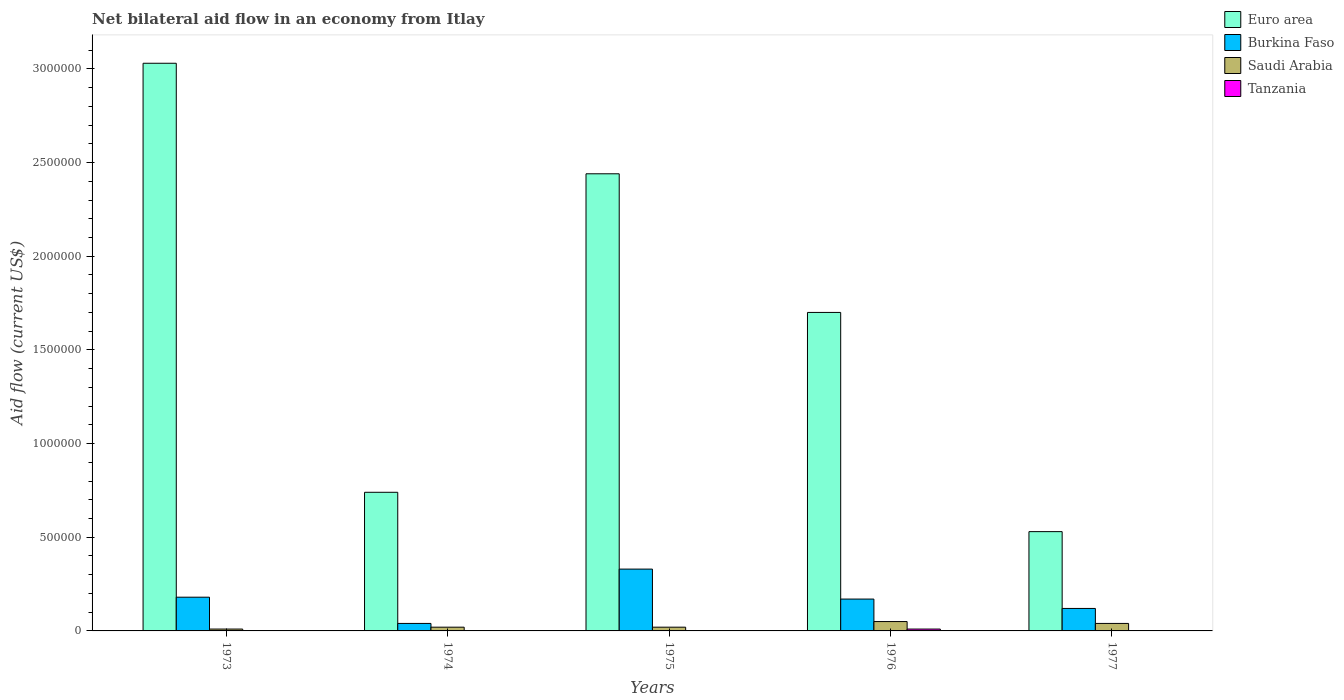How many different coloured bars are there?
Ensure brevity in your answer.  4. How many groups of bars are there?
Provide a short and direct response. 5. Are the number of bars per tick equal to the number of legend labels?
Provide a short and direct response. No. Are the number of bars on each tick of the X-axis equal?
Give a very brief answer. No. In how many cases, is the number of bars for a given year not equal to the number of legend labels?
Make the answer very short. 4. What is the net bilateral aid flow in Burkina Faso in 1974?
Your answer should be very brief. 4.00e+04. What is the total net bilateral aid flow in Euro area in the graph?
Your answer should be compact. 8.44e+06. What is the difference between the net bilateral aid flow in Euro area in 1974 and that in 1976?
Offer a very short reply. -9.60e+05. What is the difference between the net bilateral aid flow in Euro area in 1975 and the net bilateral aid flow in Burkina Faso in 1973?
Provide a succinct answer. 2.26e+06. What is the average net bilateral aid flow in Saudi Arabia per year?
Ensure brevity in your answer.  2.80e+04. In the year 1977, what is the difference between the net bilateral aid flow in Saudi Arabia and net bilateral aid flow in Euro area?
Give a very brief answer. -4.90e+05. In how many years, is the net bilateral aid flow in Burkina Faso greater than 2300000 US$?
Offer a very short reply. 0. Is the difference between the net bilateral aid flow in Saudi Arabia in 1973 and 1977 greater than the difference between the net bilateral aid flow in Euro area in 1973 and 1977?
Provide a succinct answer. No. What is the difference between the highest and the lowest net bilateral aid flow in Tanzania?
Your answer should be very brief. 10000. In how many years, is the net bilateral aid flow in Euro area greater than the average net bilateral aid flow in Euro area taken over all years?
Provide a succinct answer. 3. Is it the case that in every year, the sum of the net bilateral aid flow in Saudi Arabia and net bilateral aid flow in Tanzania is greater than the sum of net bilateral aid flow in Euro area and net bilateral aid flow in Burkina Faso?
Provide a short and direct response. No. Is it the case that in every year, the sum of the net bilateral aid flow in Burkina Faso and net bilateral aid flow in Tanzania is greater than the net bilateral aid flow in Saudi Arabia?
Your response must be concise. Yes. How many bars are there?
Ensure brevity in your answer.  16. How many years are there in the graph?
Your answer should be compact. 5. Does the graph contain any zero values?
Make the answer very short. Yes. Does the graph contain grids?
Your response must be concise. No. What is the title of the graph?
Your response must be concise. Net bilateral aid flow in an economy from Itlay. Does "Middle East & North Africa (all income levels)" appear as one of the legend labels in the graph?
Offer a terse response. No. What is the label or title of the X-axis?
Your answer should be compact. Years. What is the Aid flow (current US$) of Euro area in 1973?
Offer a very short reply. 3.03e+06. What is the Aid flow (current US$) of Saudi Arabia in 1973?
Offer a terse response. 10000. What is the Aid flow (current US$) in Euro area in 1974?
Your answer should be compact. 7.40e+05. What is the Aid flow (current US$) in Tanzania in 1974?
Your answer should be compact. 0. What is the Aid flow (current US$) in Euro area in 1975?
Your answer should be compact. 2.44e+06. What is the Aid flow (current US$) in Burkina Faso in 1975?
Your answer should be compact. 3.30e+05. What is the Aid flow (current US$) of Saudi Arabia in 1975?
Your answer should be compact. 2.00e+04. What is the Aid flow (current US$) of Euro area in 1976?
Your response must be concise. 1.70e+06. What is the Aid flow (current US$) in Burkina Faso in 1976?
Provide a short and direct response. 1.70e+05. What is the Aid flow (current US$) of Tanzania in 1976?
Give a very brief answer. 10000. What is the Aid flow (current US$) of Euro area in 1977?
Give a very brief answer. 5.30e+05. Across all years, what is the maximum Aid flow (current US$) in Euro area?
Your answer should be compact. 3.03e+06. Across all years, what is the minimum Aid flow (current US$) in Euro area?
Your answer should be very brief. 5.30e+05. Across all years, what is the minimum Aid flow (current US$) in Burkina Faso?
Your answer should be compact. 4.00e+04. Across all years, what is the minimum Aid flow (current US$) of Tanzania?
Provide a short and direct response. 0. What is the total Aid flow (current US$) of Euro area in the graph?
Your answer should be very brief. 8.44e+06. What is the total Aid flow (current US$) of Burkina Faso in the graph?
Offer a very short reply. 8.40e+05. What is the total Aid flow (current US$) in Saudi Arabia in the graph?
Your answer should be very brief. 1.40e+05. What is the difference between the Aid flow (current US$) in Euro area in 1973 and that in 1974?
Offer a very short reply. 2.29e+06. What is the difference between the Aid flow (current US$) in Euro area in 1973 and that in 1975?
Offer a very short reply. 5.90e+05. What is the difference between the Aid flow (current US$) in Burkina Faso in 1973 and that in 1975?
Your response must be concise. -1.50e+05. What is the difference between the Aid flow (current US$) in Euro area in 1973 and that in 1976?
Make the answer very short. 1.33e+06. What is the difference between the Aid flow (current US$) of Euro area in 1973 and that in 1977?
Your answer should be very brief. 2.50e+06. What is the difference between the Aid flow (current US$) in Burkina Faso in 1973 and that in 1977?
Provide a short and direct response. 6.00e+04. What is the difference between the Aid flow (current US$) in Euro area in 1974 and that in 1975?
Keep it short and to the point. -1.70e+06. What is the difference between the Aid flow (current US$) in Burkina Faso in 1974 and that in 1975?
Offer a very short reply. -2.90e+05. What is the difference between the Aid flow (current US$) in Saudi Arabia in 1974 and that in 1975?
Give a very brief answer. 0. What is the difference between the Aid flow (current US$) in Euro area in 1974 and that in 1976?
Offer a terse response. -9.60e+05. What is the difference between the Aid flow (current US$) of Burkina Faso in 1974 and that in 1976?
Provide a succinct answer. -1.30e+05. What is the difference between the Aid flow (current US$) of Saudi Arabia in 1974 and that in 1977?
Offer a very short reply. -2.00e+04. What is the difference between the Aid flow (current US$) in Euro area in 1975 and that in 1976?
Provide a short and direct response. 7.40e+05. What is the difference between the Aid flow (current US$) in Saudi Arabia in 1975 and that in 1976?
Your answer should be compact. -3.00e+04. What is the difference between the Aid flow (current US$) of Euro area in 1975 and that in 1977?
Provide a short and direct response. 1.91e+06. What is the difference between the Aid flow (current US$) of Saudi Arabia in 1975 and that in 1977?
Your answer should be very brief. -2.00e+04. What is the difference between the Aid flow (current US$) of Euro area in 1976 and that in 1977?
Make the answer very short. 1.17e+06. What is the difference between the Aid flow (current US$) in Saudi Arabia in 1976 and that in 1977?
Give a very brief answer. 10000. What is the difference between the Aid flow (current US$) of Euro area in 1973 and the Aid flow (current US$) of Burkina Faso in 1974?
Make the answer very short. 2.99e+06. What is the difference between the Aid flow (current US$) in Euro area in 1973 and the Aid flow (current US$) in Saudi Arabia in 1974?
Provide a succinct answer. 3.01e+06. What is the difference between the Aid flow (current US$) in Euro area in 1973 and the Aid flow (current US$) in Burkina Faso in 1975?
Your answer should be compact. 2.70e+06. What is the difference between the Aid flow (current US$) of Euro area in 1973 and the Aid flow (current US$) of Saudi Arabia in 1975?
Give a very brief answer. 3.01e+06. What is the difference between the Aid flow (current US$) of Burkina Faso in 1973 and the Aid flow (current US$) of Saudi Arabia in 1975?
Offer a very short reply. 1.60e+05. What is the difference between the Aid flow (current US$) of Euro area in 1973 and the Aid flow (current US$) of Burkina Faso in 1976?
Offer a very short reply. 2.86e+06. What is the difference between the Aid flow (current US$) in Euro area in 1973 and the Aid flow (current US$) in Saudi Arabia in 1976?
Provide a succinct answer. 2.98e+06. What is the difference between the Aid flow (current US$) in Euro area in 1973 and the Aid flow (current US$) in Tanzania in 1976?
Keep it short and to the point. 3.02e+06. What is the difference between the Aid flow (current US$) in Burkina Faso in 1973 and the Aid flow (current US$) in Tanzania in 1976?
Provide a succinct answer. 1.70e+05. What is the difference between the Aid flow (current US$) of Euro area in 1973 and the Aid flow (current US$) of Burkina Faso in 1977?
Your response must be concise. 2.91e+06. What is the difference between the Aid flow (current US$) of Euro area in 1973 and the Aid flow (current US$) of Saudi Arabia in 1977?
Your answer should be compact. 2.99e+06. What is the difference between the Aid flow (current US$) in Burkina Faso in 1973 and the Aid flow (current US$) in Saudi Arabia in 1977?
Make the answer very short. 1.40e+05. What is the difference between the Aid flow (current US$) in Euro area in 1974 and the Aid flow (current US$) in Burkina Faso in 1975?
Provide a succinct answer. 4.10e+05. What is the difference between the Aid flow (current US$) of Euro area in 1974 and the Aid flow (current US$) of Saudi Arabia in 1975?
Your response must be concise. 7.20e+05. What is the difference between the Aid flow (current US$) in Burkina Faso in 1974 and the Aid flow (current US$) in Saudi Arabia in 1975?
Your answer should be compact. 2.00e+04. What is the difference between the Aid flow (current US$) of Euro area in 1974 and the Aid flow (current US$) of Burkina Faso in 1976?
Offer a terse response. 5.70e+05. What is the difference between the Aid flow (current US$) of Euro area in 1974 and the Aid flow (current US$) of Saudi Arabia in 1976?
Offer a very short reply. 6.90e+05. What is the difference between the Aid flow (current US$) of Euro area in 1974 and the Aid flow (current US$) of Tanzania in 1976?
Ensure brevity in your answer.  7.30e+05. What is the difference between the Aid flow (current US$) of Euro area in 1974 and the Aid flow (current US$) of Burkina Faso in 1977?
Offer a terse response. 6.20e+05. What is the difference between the Aid flow (current US$) in Euro area in 1974 and the Aid flow (current US$) in Saudi Arabia in 1977?
Provide a short and direct response. 7.00e+05. What is the difference between the Aid flow (current US$) of Burkina Faso in 1974 and the Aid flow (current US$) of Saudi Arabia in 1977?
Your answer should be compact. 0. What is the difference between the Aid flow (current US$) of Euro area in 1975 and the Aid flow (current US$) of Burkina Faso in 1976?
Your answer should be compact. 2.27e+06. What is the difference between the Aid flow (current US$) of Euro area in 1975 and the Aid flow (current US$) of Saudi Arabia in 1976?
Keep it short and to the point. 2.39e+06. What is the difference between the Aid flow (current US$) in Euro area in 1975 and the Aid flow (current US$) in Tanzania in 1976?
Give a very brief answer. 2.43e+06. What is the difference between the Aid flow (current US$) of Burkina Faso in 1975 and the Aid flow (current US$) of Saudi Arabia in 1976?
Offer a terse response. 2.80e+05. What is the difference between the Aid flow (current US$) in Burkina Faso in 1975 and the Aid flow (current US$) in Tanzania in 1976?
Give a very brief answer. 3.20e+05. What is the difference between the Aid flow (current US$) of Euro area in 1975 and the Aid flow (current US$) of Burkina Faso in 1977?
Give a very brief answer. 2.32e+06. What is the difference between the Aid flow (current US$) of Euro area in 1975 and the Aid flow (current US$) of Saudi Arabia in 1977?
Provide a succinct answer. 2.40e+06. What is the difference between the Aid flow (current US$) in Euro area in 1976 and the Aid flow (current US$) in Burkina Faso in 1977?
Offer a very short reply. 1.58e+06. What is the difference between the Aid flow (current US$) in Euro area in 1976 and the Aid flow (current US$) in Saudi Arabia in 1977?
Make the answer very short. 1.66e+06. What is the average Aid flow (current US$) in Euro area per year?
Offer a terse response. 1.69e+06. What is the average Aid flow (current US$) of Burkina Faso per year?
Make the answer very short. 1.68e+05. What is the average Aid flow (current US$) of Saudi Arabia per year?
Keep it short and to the point. 2.80e+04. What is the average Aid flow (current US$) in Tanzania per year?
Your answer should be very brief. 2000. In the year 1973, what is the difference between the Aid flow (current US$) of Euro area and Aid flow (current US$) of Burkina Faso?
Your response must be concise. 2.85e+06. In the year 1973, what is the difference between the Aid flow (current US$) of Euro area and Aid flow (current US$) of Saudi Arabia?
Make the answer very short. 3.02e+06. In the year 1973, what is the difference between the Aid flow (current US$) in Burkina Faso and Aid flow (current US$) in Saudi Arabia?
Provide a short and direct response. 1.70e+05. In the year 1974, what is the difference between the Aid flow (current US$) of Euro area and Aid flow (current US$) of Burkina Faso?
Keep it short and to the point. 7.00e+05. In the year 1974, what is the difference between the Aid flow (current US$) of Euro area and Aid flow (current US$) of Saudi Arabia?
Offer a very short reply. 7.20e+05. In the year 1975, what is the difference between the Aid flow (current US$) of Euro area and Aid flow (current US$) of Burkina Faso?
Offer a terse response. 2.11e+06. In the year 1975, what is the difference between the Aid flow (current US$) of Euro area and Aid flow (current US$) of Saudi Arabia?
Offer a very short reply. 2.42e+06. In the year 1976, what is the difference between the Aid flow (current US$) in Euro area and Aid flow (current US$) in Burkina Faso?
Give a very brief answer. 1.53e+06. In the year 1976, what is the difference between the Aid flow (current US$) of Euro area and Aid flow (current US$) of Saudi Arabia?
Provide a short and direct response. 1.65e+06. In the year 1976, what is the difference between the Aid flow (current US$) of Euro area and Aid flow (current US$) of Tanzania?
Offer a very short reply. 1.69e+06. What is the ratio of the Aid flow (current US$) in Euro area in 1973 to that in 1974?
Your response must be concise. 4.09. What is the ratio of the Aid flow (current US$) of Saudi Arabia in 1973 to that in 1974?
Provide a succinct answer. 0.5. What is the ratio of the Aid flow (current US$) of Euro area in 1973 to that in 1975?
Your answer should be very brief. 1.24. What is the ratio of the Aid flow (current US$) of Burkina Faso in 1973 to that in 1975?
Offer a very short reply. 0.55. What is the ratio of the Aid flow (current US$) in Euro area in 1973 to that in 1976?
Provide a short and direct response. 1.78. What is the ratio of the Aid flow (current US$) in Burkina Faso in 1973 to that in 1976?
Keep it short and to the point. 1.06. What is the ratio of the Aid flow (current US$) in Saudi Arabia in 1973 to that in 1976?
Your response must be concise. 0.2. What is the ratio of the Aid flow (current US$) in Euro area in 1973 to that in 1977?
Provide a succinct answer. 5.72. What is the ratio of the Aid flow (current US$) in Burkina Faso in 1973 to that in 1977?
Make the answer very short. 1.5. What is the ratio of the Aid flow (current US$) in Euro area in 1974 to that in 1975?
Offer a terse response. 0.3. What is the ratio of the Aid flow (current US$) of Burkina Faso in 1974 to that in 1975?
Your response must be concise. 0.12. What is the ratio of the Aid flow (current US$) in Saudi Arabia in 1974 to that in 1975?
Make the answer very short. 1. What is the ratio of the Aid flow (current US$) in Euro area in 1974 to that in 1976?
Offer a very short reply. 0.44. What is the ratio of the Aid flow (current US$) of Burkina Faso in 1974 to that in 1976?
Make the answer very short. 0.24. What is the ratio of the Aid flow (current US$) in Euro area in 1974 to that in 1977?
Your response must be concise. 1.4. What is the ratio of the Aid flow (current US$) of Euro area in 1975 to that in 1976?
Your answer should be compact. 1.44. What is the ratio of the Aid flow (current US$) of Burkina Faso in 1975 to that in 1976?
Offer a terse response. 1.94. What is the ratio of the Aid flow (current US$) of Saudi Arabia in 1975 to that in 1976?
Your answer should be compact. 0.4. What is the ratio of the Aid flow (current US$) of Euro area in 1975 to that in 1977?
Give a very brief answer. 4.6. What is the ratio of the Aid flow (current US$) of Burkina Faso in 1975 to that in 1977?
Make the answer very short. 2.75. What is the ratio of the Aid flow (current US$) in Euro area in 1976 to that in 1977?
Ensure brevity in your answer.  3.21. What is the ratio of the Aid flow (current US$) in Burkina Faso in 1976 to that in 1977?
Offer a very short reply. 1.42. What is the difference between the highest and the second highest Aid flow (current US$) of Euro area?
Offer a very short reply. 5.90e+05. What is the difference between the highest and the second highest Aid flow (current US$) of Saudi Arabia?
Provide a short and direct response. 10000. What is the difference between the highest and the lowest Aid flow (current US$) of Euro area?
Offer a very short reply. 2.50e+06. What is the difference between the highest and the lowest Aid flow (current US$) of Tanzania?
Provide a succinct answer. 10000. 